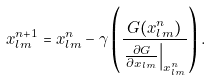Convert formula to latex. <formula><loc_0><loc_0><loc_500><loc_500>x _ { l m } ^ { n + 1 } = x _ { l m } ^ { n } - \gamma \left ( \frac { G ( x _ { l m } ^ { n } ) } { \left . \frac { \partial G } { \partial x _ { l m } } \right | _ { x _ { l m } ^ { n } } } \right ) .</formula> 